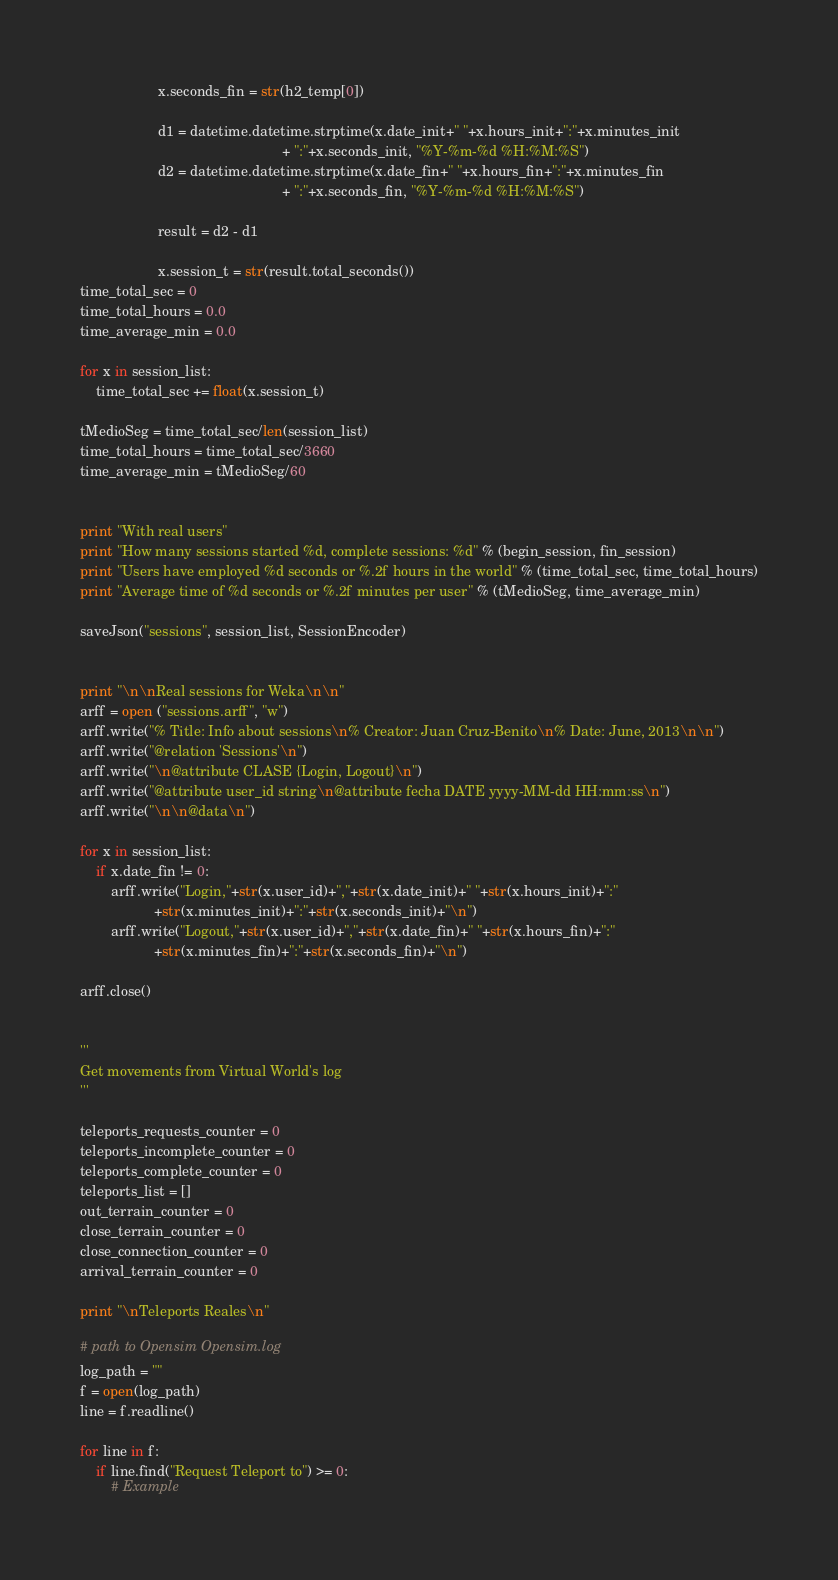<code> <loc_0><loc_0><loc_500><loc_500><_Python_>                    x.seconds_fin = str(h2_temp[0])

                    d1 = datetime.datetime.strptime(x.date_init+" "+x.hours_init+":"+x.minutes_init
                                                    + ":"+x.seconds_init, "%Y-%m-%d %H:%M:%S")
                    d2 = datetime.datetime.strptime(x.date_fin+" "+x.hours_fin+":"+x.minutes_fin
                                                    + ":"+x.seconds_fin, "%Y-%m-%d %H:%M:%S")

                    result = d2 - d1

                    x.session_t = str(result.total_seconds())
time_total_sec = 0
time_total_hours = 0.0
time_average_min = 0.0

for x in session_list:
    time_total_sec += float(x.session_t)

tMedioSeg = time_total_sec/len(session_list)
time_total_hours = time_total_sec/3660
time_average_min = tMedioSeg/60


print "With real users"
print "How many sessions started %d, complete sessions: %d" % (begin_session, fin_session)
print "Users have employed %d seconds or %.2f hours in the world" % (time_total_sec, time_total_hours)
print "Average time of %d seconds or %.2f minutes per user" % (tMedioSeg, time_average_min)

saveJson("sessions", session_list, SessionEncoder)


print "\n\nReal sessions for Weka\n\n"
arff = open ("sessions.arff", "w")
arff.write("% Title: Info about sessions\n% Creator: Juan Cruz-Benito\n% Date: June, 2013\n\n")
arff.write("@relation 'Sessions'\n")
arff.write("\n@attribute CLASE {Login, Logout}\n")
arff.write("@attribute user_id string\n@attribute fecha DATE yyyy-MM-dd HH:mm:ss\n")
arff.write("\n\n@data\n")

for x in session_list:
    if x.date_fin != 0:
        arff.write("Login,"+str(x.user_id)+","+str(x.date_init)+" "+str(x.hours_init)+":"
                   +str(x.minutes_init)+":"+str(x.seconds_init)+"\n")
        arff.write("Logout,"+str(x.user_id)+","+str(x.date_fin)+" "+str(x.hours_fin)+":"
                   +str(x.minutes_fin)+":"+str(x.seconds_fin)+"\n")

arff.close()


'''
Get movements from Virtual World's log 
'''

teleports_requests_counter = 0
teleports_incomplete_counter = 0
teleports_complete_counter = 0
teleports_list = []
out_terrain_counter = 0
close_terrain_counter = 0
close_connection_counter = 0
arrival_terrain_counter = 0

print "\nTeleports Reales\n"

# path to Opensim Opensim.log
log_path = ""
f = open(log_path)
line = f.readline()

for line in f:
    if line.find("Request Teleport to") >= 0:
        # Example</code> 